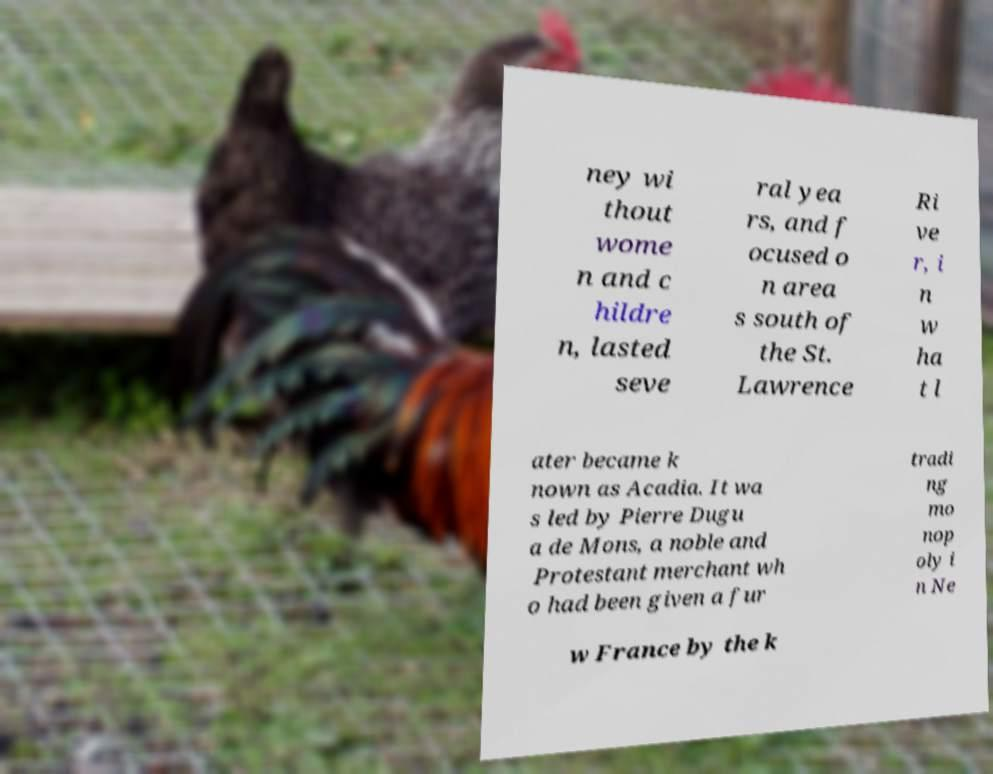For documentation purposes, I need the text within this image transcribed. Could you provide that? ney wi thout wome n and c hildre n, lasted seve ral yea rs, and f ocused o n area s south of the St. Lawrence Ri ve r, i n w ha t l ater became k nown as Acadia. It wa s led by Pierre Dugu a de Mons, a noble and Protestant merchant wh o had been given a fur tradi ng mo nop oly i n Ne w France by the k 